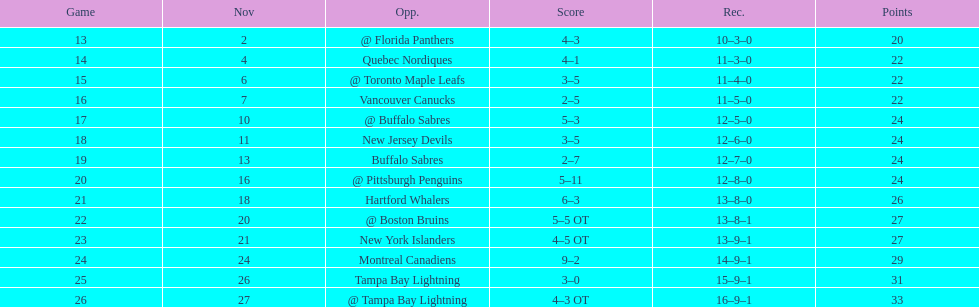What was the number of wins the philadelphia flyers had? 35. 